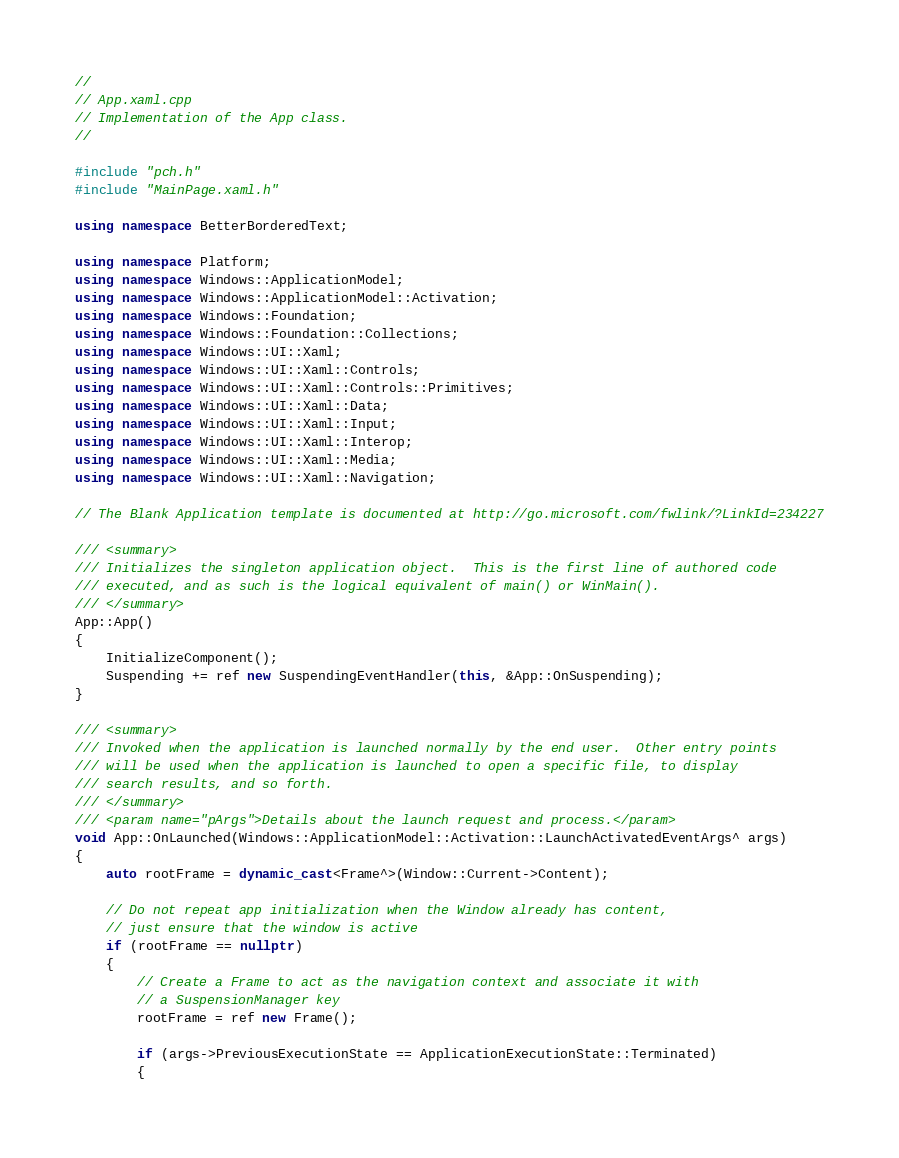<code> <loc_0><loc_0><loc_500><loc_500><_C++_>//
// App.xaml.cpp
// Implementation of the App class.
//

#include "pch.h"
#include "MainPage.xaml.h"

using namespace BetterBorderedText;

using namespace Platform;
using namespace Windows::ApplicationModel;
using namespace Windows::ApplicationModel::Activation;
using namespace Windows::Foundation;
using namespace Windows::Foundation::Collections;
using namespace Windows::UI::Xaml;
using namespace Windows::UI::Xaml::Controls;
using namespace Windows::UI::Xaml::Controls::Primitives;
using namespace Windows::UI::Xaml::Data;
using namespace Windows::UI::Xaml::Input;
using namespace Windows::UI::Xaml::Interop;
using namespace Windows::UI::Xaml::Media;
using namespace Windows::UI::Xaml::Navigation;

// The Blank Application template is documented at http://go.microsoft.com/fwlink/?LinkId=234227

/// <summary>
/// Initializes the singleton application object.  This is the first line of authored code
/// executed, and as such is the logical equivalent of main() or WinMain().
/// </summary>
App::App()
{
    InitializeComponent();
    Suspending += ref new SuspendingEventHandler(this, &App::OnSuspending);
}

/// <summary>
/// Invoked when the application is launched normally by the end user.  Other entry points
/// will be used when the application is launched to open a specific file, to display
/// search results, and so forth.
/// </summary>
/// <param name="pArgs">Details about the launch request and process.</param>
void App::OnLaunched(Windows::ApplicationModel::Activation::LaunchActivatedEventArgs^ args)
{
    auto rootFrame = dynamic_cast<Frame^>(Window::Current->Content);

    // Do not repeat app initialization when the Window already has content,
    // just ensure that the window is active
    if (rootFrame == nullptr)
    {
        // Create a Frame to act as the navigation context and associate it with
        // a SuspensionManager key
        rootFrame = ref new Frame();

        if (args->PreviousExecutionState == ApplicationExecutionState::Terminated)
        {</code> 